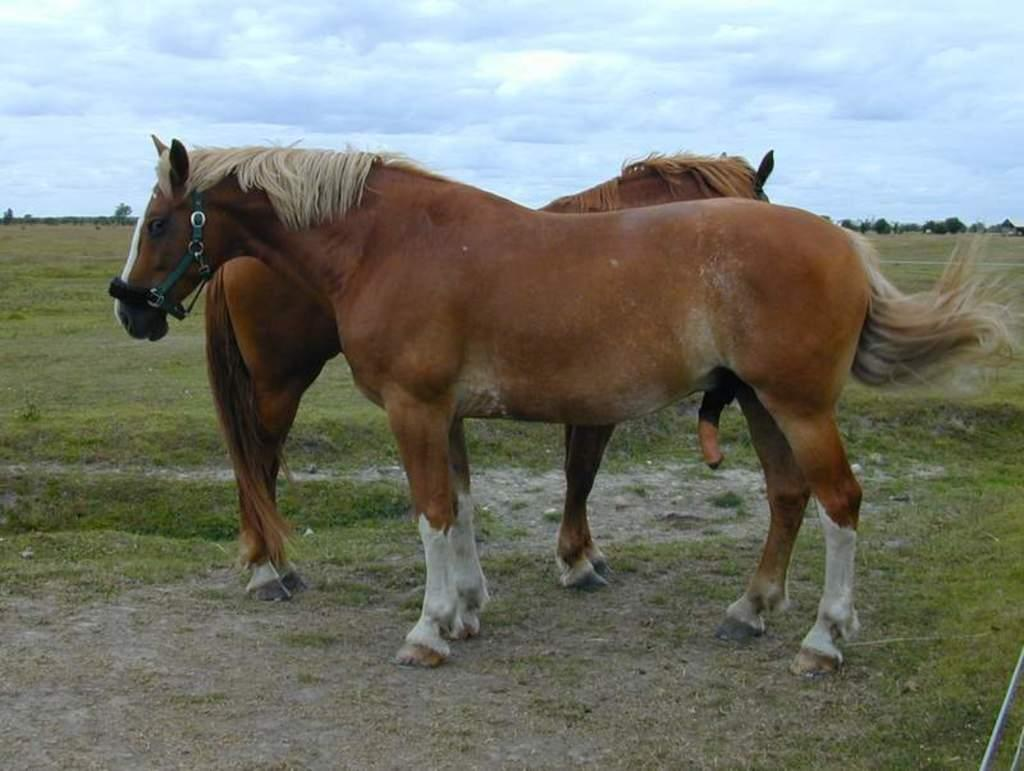How many horses are in the image? There are two horses in the image. What is on the surface where the horses are standing? There is grass on the surface in the image. What can be seen in the background of the image? There are trees and the sky visible in the background of the image. What is the reaction of the horses to the trip they are about to take in the image? There is no indication in the image that the horses are about to take a trip, nor is there any information about their reaction. 